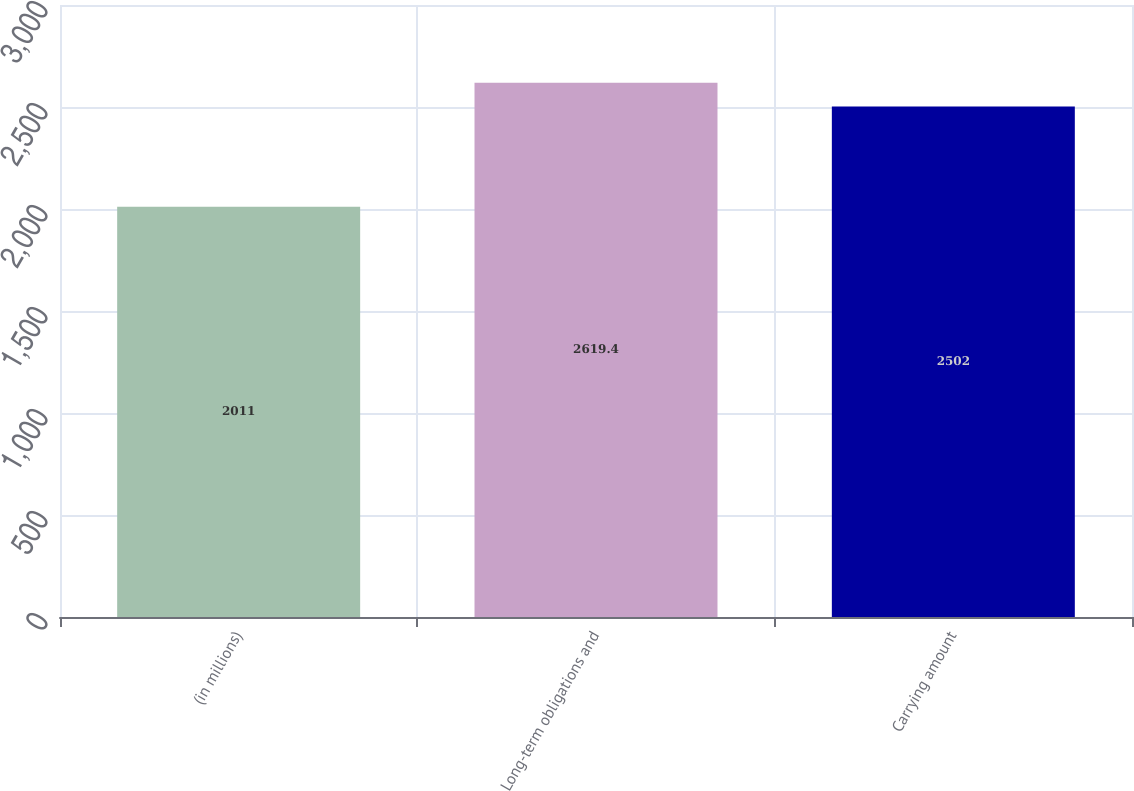<chart> <loc_0><loc_0><loc_500><loc_500><bar_chart><fcel>(in millions)<fcel>Long-term obligations and<fcel>Carrying amount<nl><fcel>2011<fcel>2619.4<fcel>2502<nl></chart> 